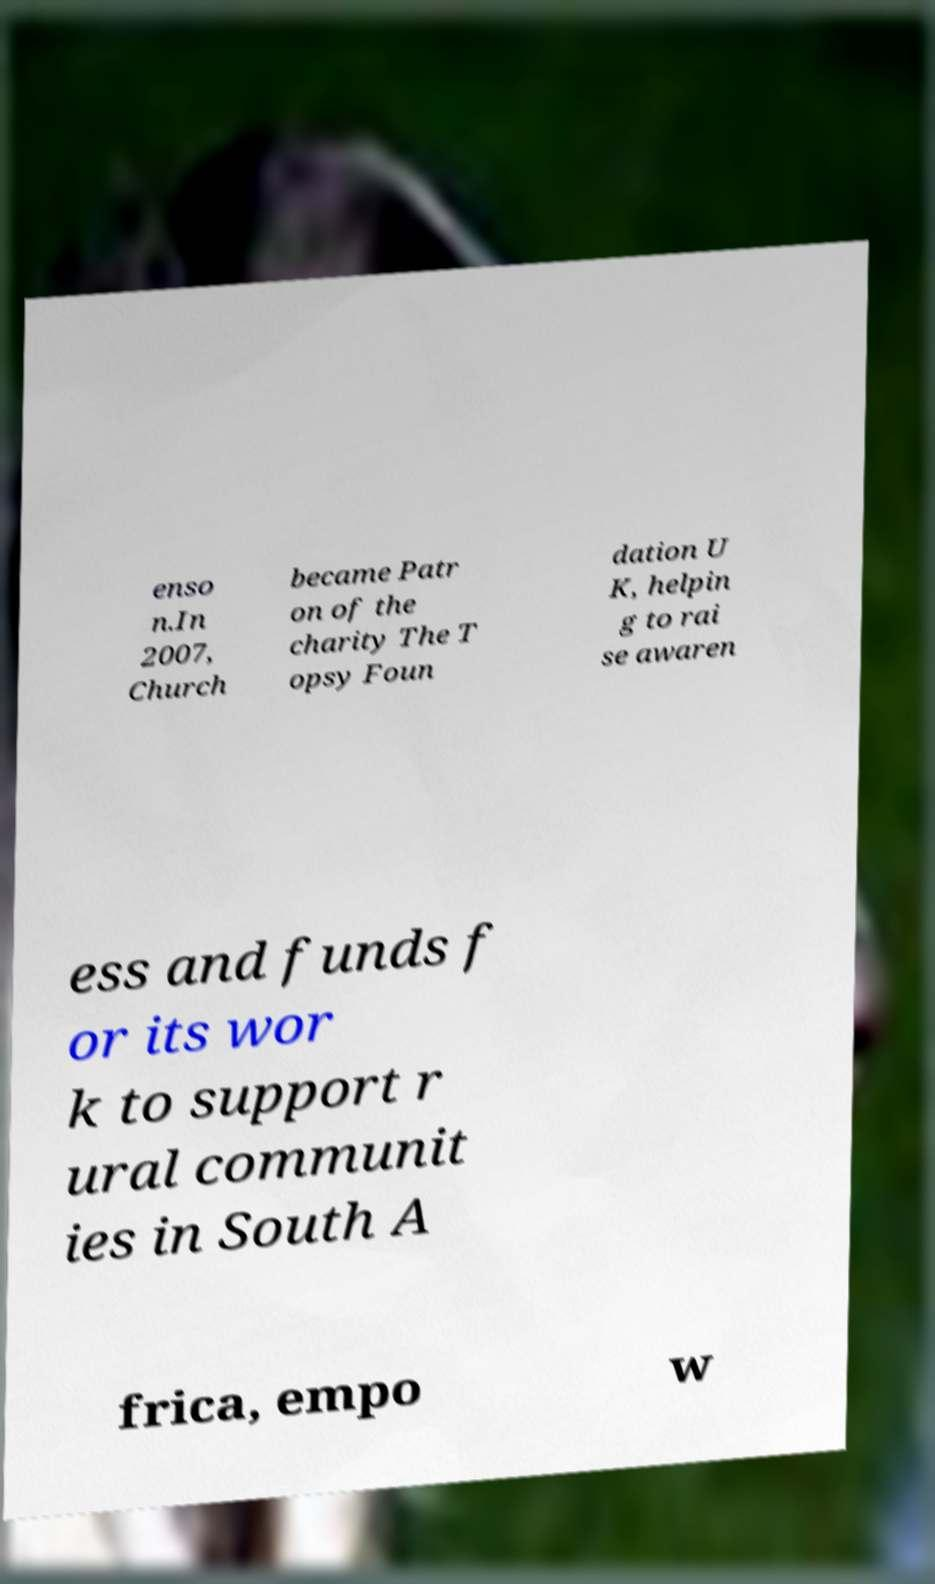I need the written content from this picture converted into text. Can you do that? enso n.In 2007, Church became Patr on of the charity The T opsy Foun dation U K, helpin g to rai se awaren ess and funds f or its wor k to support r ural communit ies in South A frica, empo w 